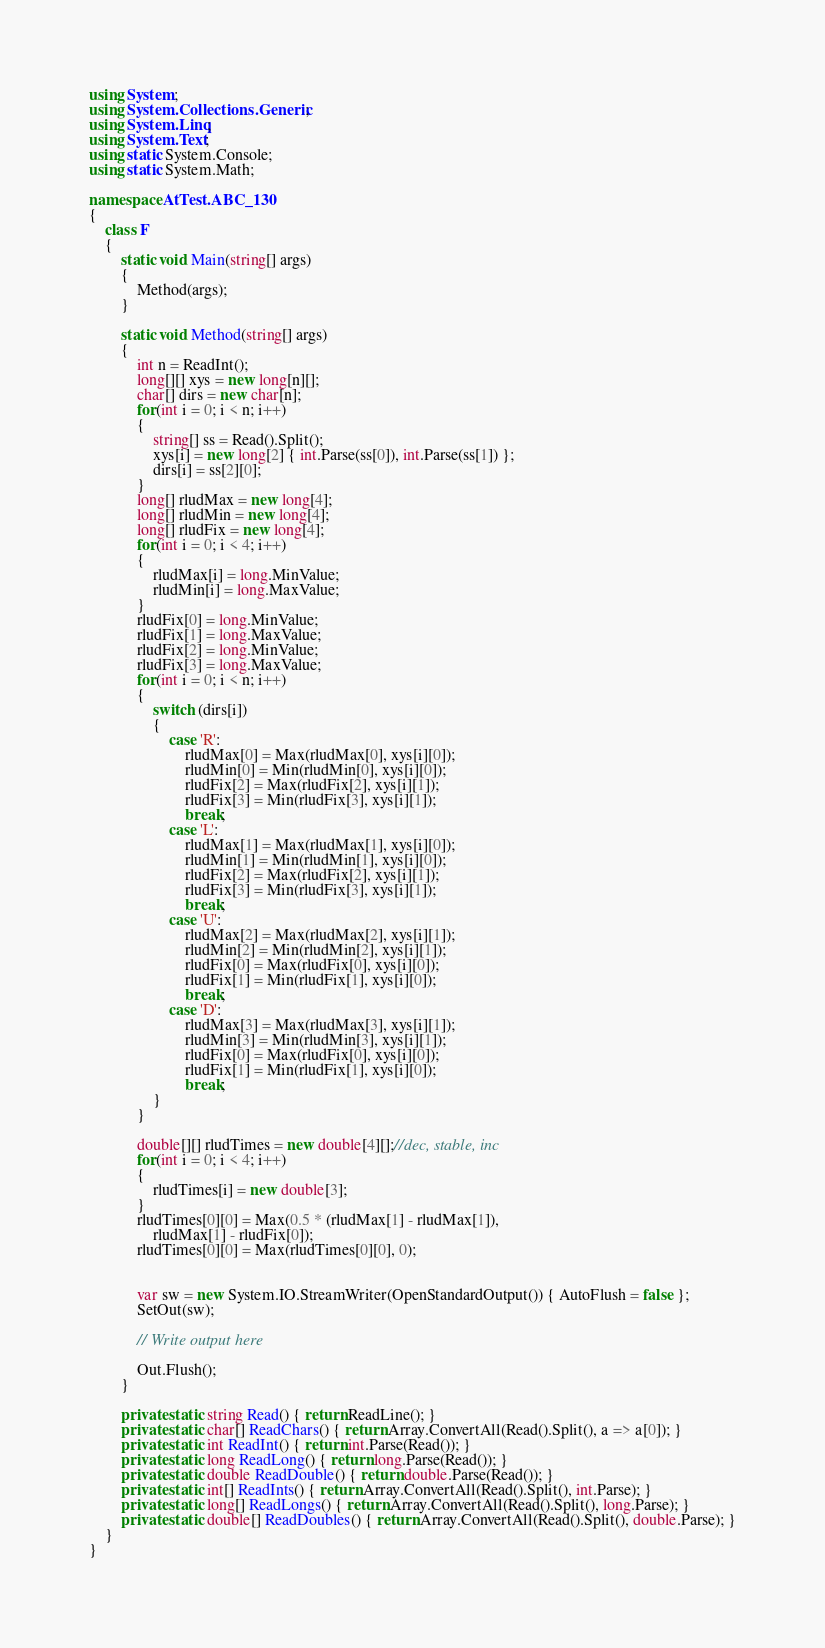<code> <loc_0><loc_0><loc_500><loc_500><_C#_>using System;
using System.Collections.Generic;
using System.Linq;
using System.Text;
using static System.Console;
using static System.Math;

namespace AtTest.ABC_130
{
    class F
    {
        static void Main(string[] args)
        {
            Method(args);
        }

        static void Method(string[] args)
        {
            int n = ReadInt();
            long[][] xys = new long[n][];
            char[] dirs = new char[n];
            for(int i = 0; i < n; i++)
            {
                string[] ss = Read().Split();
                xys[i] = new long[2] { int.Parse(ss[0]), int.Parse(ss[1]) };
                dirs[i] = ss[2][0];
            }
            long[] rludMax = new long[4];
            long[] rludMin = new long[4];
            long[] rludFix = new long[4];
            for(int i = 0; i < 4; i++)
            {
                rludMax[i] = long.MinValue;
                rludMin[i] = long.MaxValue;
            }
            rludFix[0] = long.MinValue;
            rludFix[1] = long.MaxValue;
            rludFix[2] = long.MinValue;
            rludFix[3] = long.MaxValue;
            for(int i = 0; i < n; i++)
            {
                switch (dirs[i])
                {
                    case 'R':
                        rludMax[0] = Max(rludMax[0], xys[i][0]);
                        rludMin[0] = Min(rludMin[0], xys[i][0]);
                        rludFix[2] = Max(rludFix[2], xys[i][1]);
                        rludFix[3] = Min(rludFix[3], xys[i][1]);
                        break;
                    case 'L':
                        rludMax[1] = Max(rludMax[1], xys[i][0]);
                        rludMin[1] = Min(rludMin[1], xys[i][0]);
                        rludFix[2] = Max(rludFix[2], xys[i][1]);
                        rludFix[3] = Min(rludFix[3], xys[i][1]);
                        break;
                    case 'U':
                        rludMax[2] = Max(rludMax[2], xys[i][1]);
                        rludMin[2] = Min(rludMin[2], xys[i][1]);
                        rludFix[0] = Max(rludFix[0], xys[i][0]);
                        rludFix[1] = Min(rludFix[1], xys[i][0]);
                        break;
                    case 'D':
                        rludMax[3] = Max(rludMax[3], xys[i][1]);
                        rludMin[3] = Min(rludMin[3], xys[i][1]);
                        rludFix[0] = Max(rludFix[0], xys[i][0]);
                        rludFix[1] = Min(rludFix[1], xys[i][0]);
                        break;
                }
            }

            double[][] rludTimes = new double[4][];//dec, stable, inc
            for(int i = 0; i < 4; i++)
            {
                rludTimes[i] = new double[3];
            }
            rludTimes[0][0] = Max(0.5 * (rludMax[1] - rludMax[1]),
                rludMax[1] - rludFix[0]);
            rludTimes[0][0] = Max(rludTimes[0][0], 0);


            var sw = new System.IO.StreamWriter(OpenStandardOutput()) { AutoFlush = false };
            SetOut(sw);

            // Write output here

            Out.Flush();
        }

        private static string Read() { return ReadLine(); }
        private static char[] ReadChars() { return Array.ConvertAll(Read().Split(), a => a[0]); }
        private static int ReadInt() { return int.Parse(Read()); }
        private static long ReadLong() { return long.Parse(Read()); }
        private static double ReadDouble() { return double.Parse(Read()); }
        private static int[] ReadInts() { return Array.ConvertAll(Read().Split(), int.Parse); }
        private static long[] ReadLongs() { return Array.ConvertAll(Read().Split(), long.Parse); }
        private static double[] ReadDoubles() { return Array.ConvertAll(Read().Split(), double.Parse); }
    }
}
</code> 